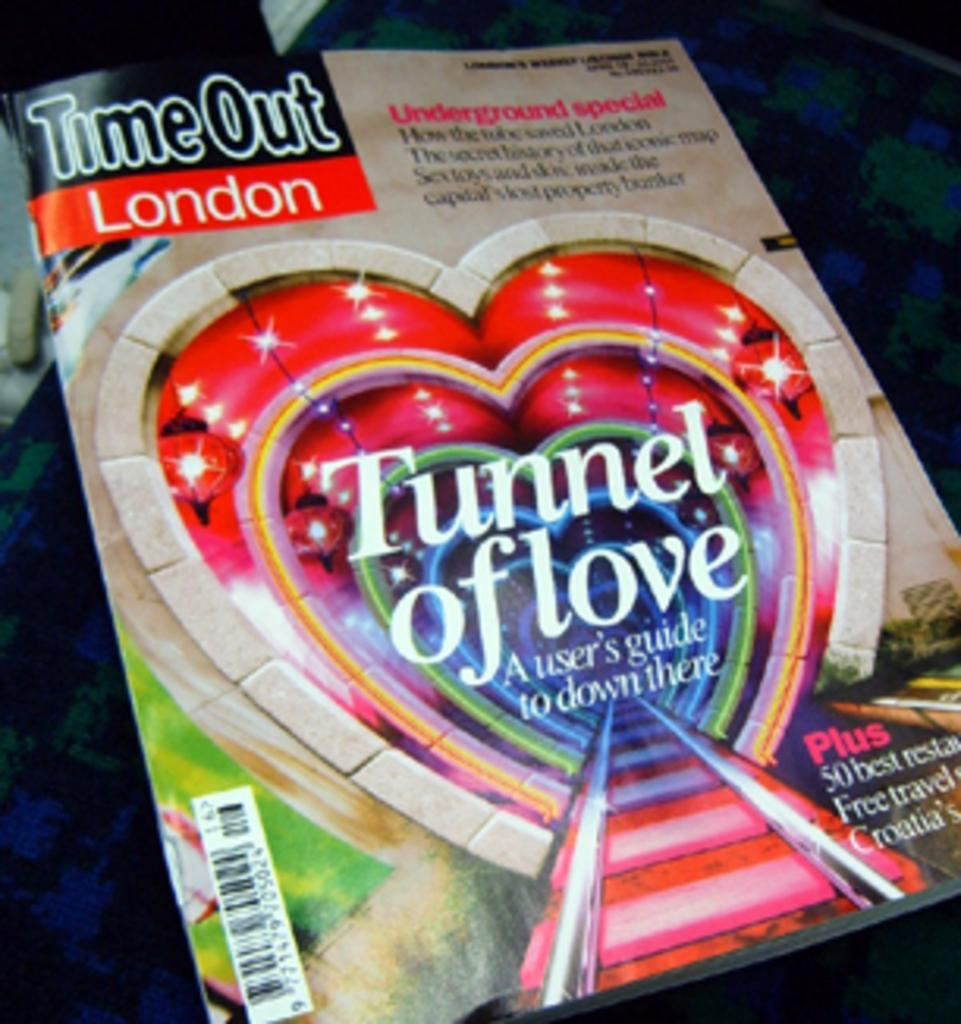Provide a one-sentence caption for the provided image. The Tunnel of Love has a user guide on how to go down there. 